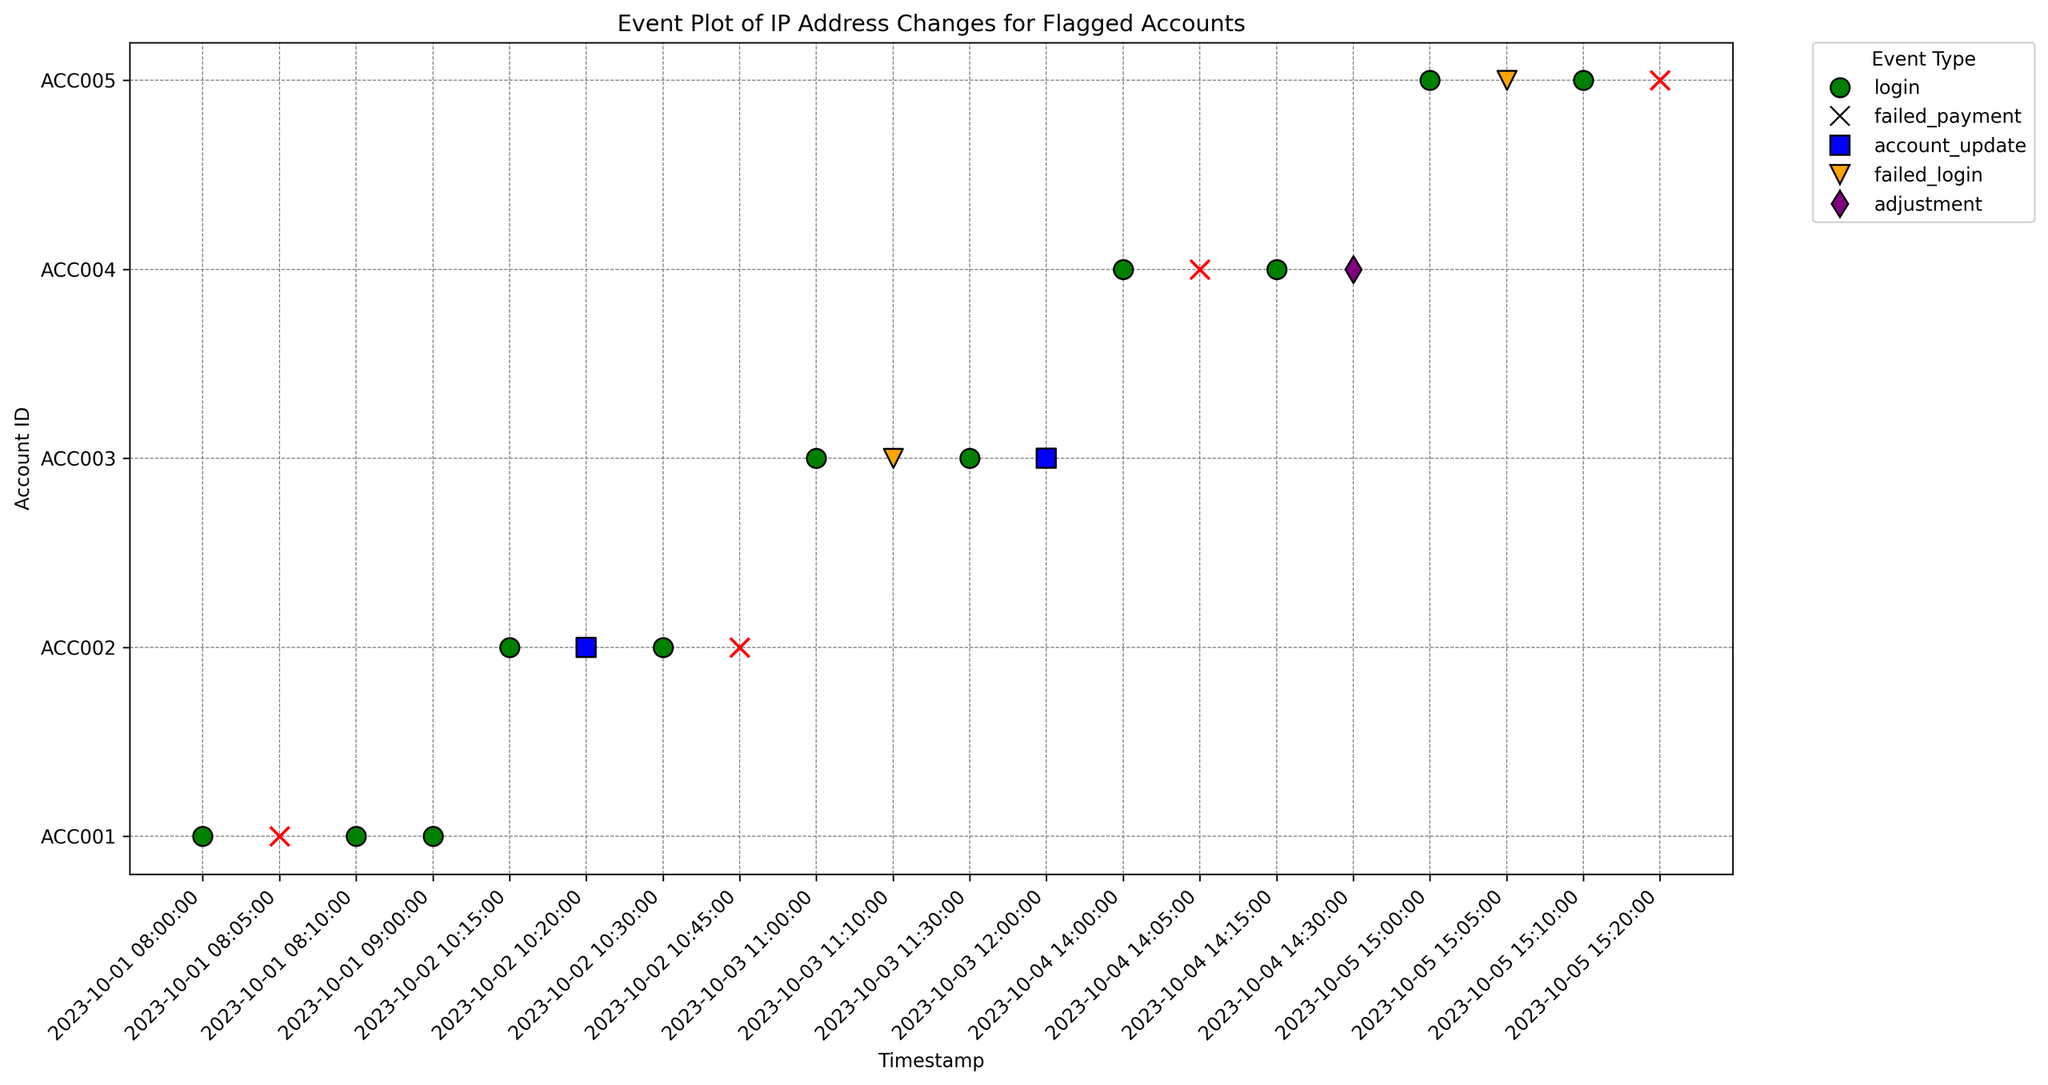What are the different event types represented by different markers? The figure uses different markers for different event types: 'o' for login (green), 'x' for failed_payment (red), 's' for account_update (blue), 'v' for failed_login (orange), and 'd' for adjustment (purple). By identifying these markers, you can determine the event types.
Answer: login, failed_payment, account_update, failed_login, adjustment Which account has the first instance of 'failed_login' event seen on the plot? To find the first instance of 'failed_login', look for the earliest orange 'v' marker on the x-axis. The first one appears for account ACC003 on 2023-10-03 at 11:10:00.
Answer: ACC003 How many IP address changes does ACC001 have between 2023-10-01 08:00:00 and 2023-10-01 09:00:00? First, filter the events by the given timestamp range (08:00:00 to 09:00:00). Then, count the different IP addresses used by ACC001 in that range: 192.168.1.1, 172.16.0.1, and back to 192.168.1.1. This results in 2 changes.
Answer: 2 Which account shows the highest variety of IP addresses in its events? Examine each account's events and count the unique IP addresses. ACC001 and ACC002 both have three unique IP addresses (192.168.1.1, 172.16.0.1, and one additional). Check other accounts similarly to confirm that ACC002 also has the highest variety.
Answer: ACC002 Between ACC004 and ACC005, which account has more events involving IP address changes? Count the number of events involving different IP addresses for each account in the plot. ACC004 has 4 events (all with IP changes), and ACC005 has 4 events as well (with 2 different IPs). The difference is in the number of different IP addresses. ACC004 uses 4 different IP addresses, while ACC005 changes just once.
Answer: ACC004 Identify the account with the most failed payment events. Identify which account has the most red 'x' markers on the plot. Both ACC001, ACC002, and ACC005 each have one 'failed_payment' event. Compare across all accounts; look for the highest occurrence.
Answer: ACC004 and ACC005 (1 each) Which account has the most frequent changes in IP address within the shortest time span? Observe the timestamp and IP address for each account's events. Find the account with multiple IP changes in quick succession. ACC001 changes IPs twice within 10 minutes (08:10 to 08:20). Verify if any other account has more frequent changes in a shorter interval.
Answer: ACC001 How many adjustment events are present in the figure? Count the number of purple 'd' markers representing adjustment events across all accounts in the plot. There is only one purple 'd' marker on the plot, associated with ACC004.
Answer: 1 